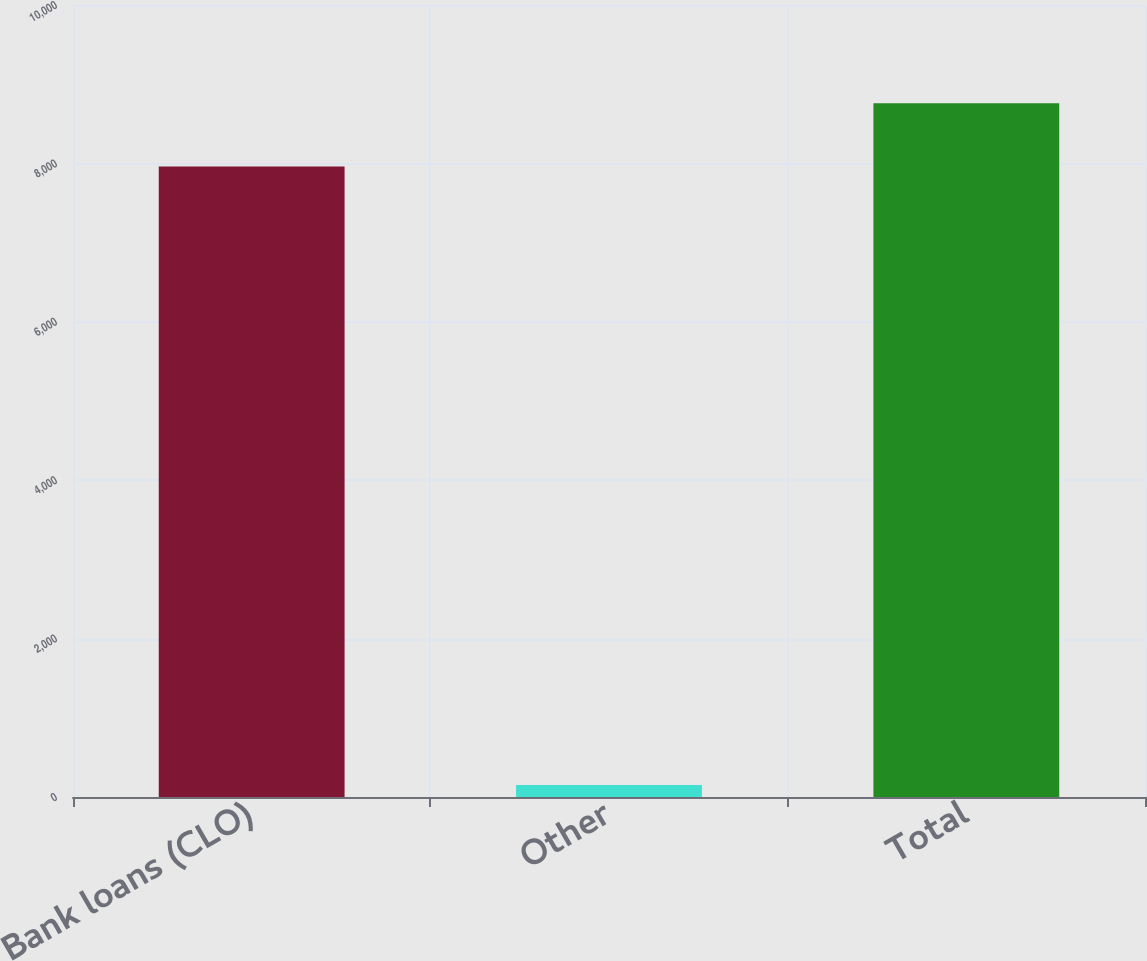Convert chart. <chart><loc_0><loc_0><loc_500><loc_500><bar_chart><fcel>Bank loans (CLO)<fcel>Other<fcel>Total<nl><fcel>7962<fcel>153<fcel>8758.2<nl></chart> 